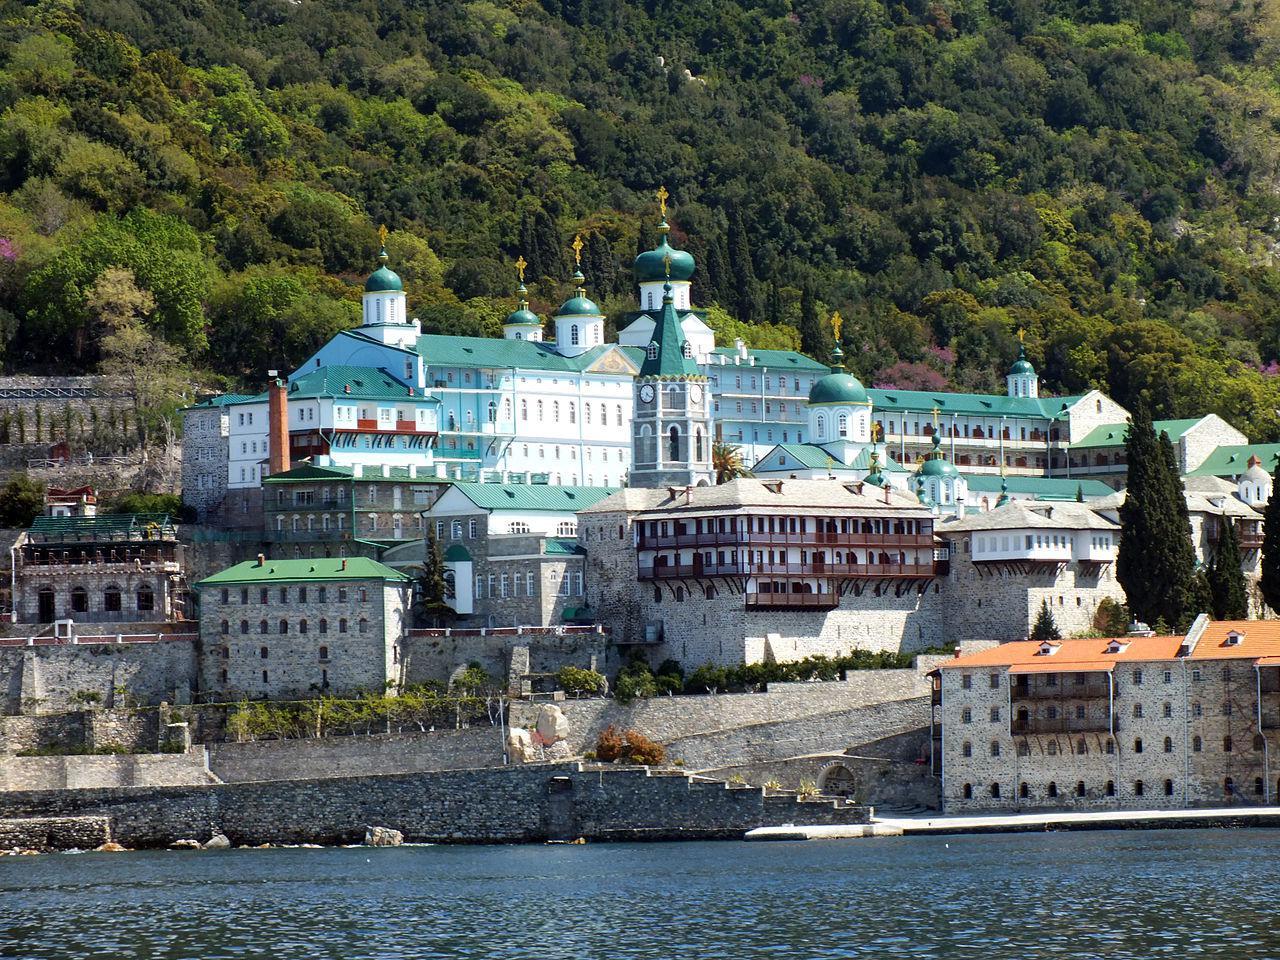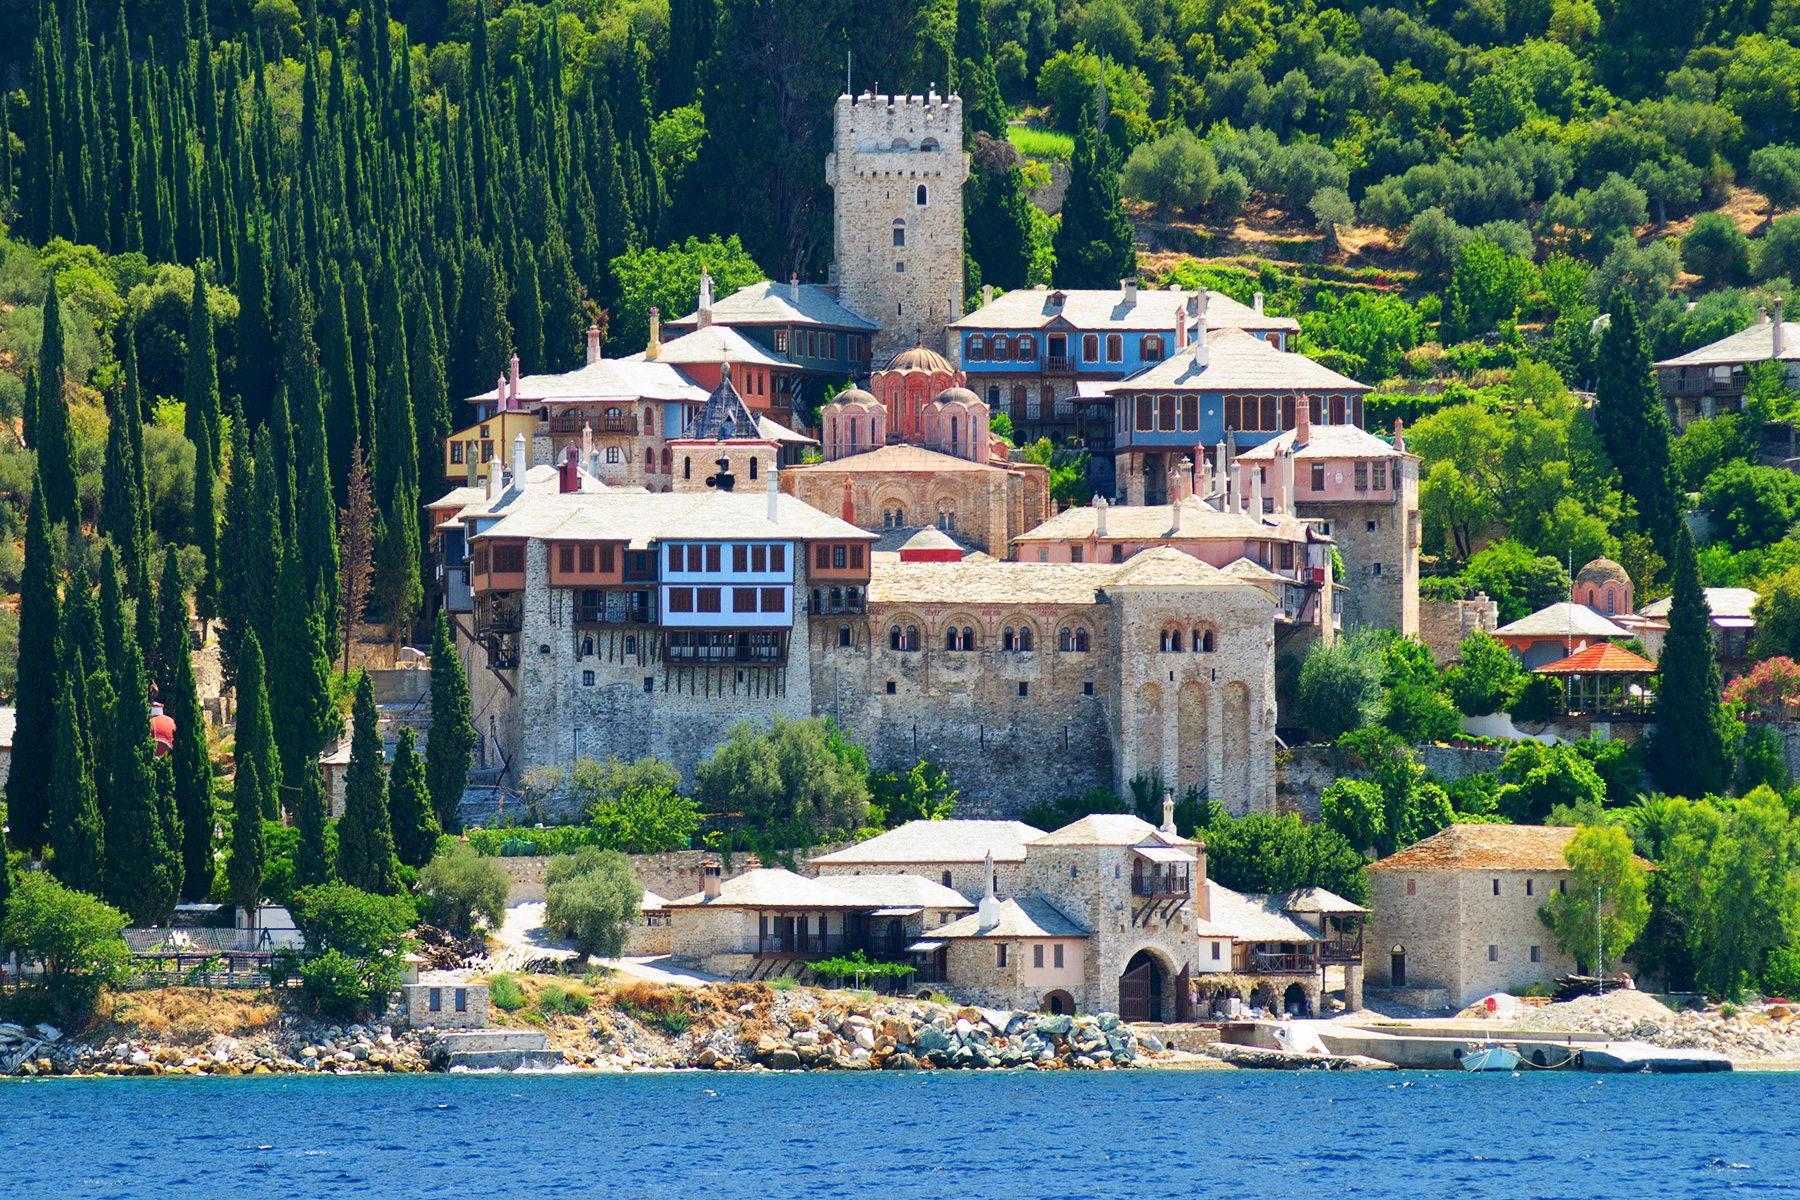The first image is the image on the left, the second image is the image on the right. Analyze the images presented: Is the assertion "There are hazy clouds in the image on the right." valid? Answer yes or no. No. 